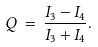<formula> <loc_0><loc_0><loc_500><loc_500>Q \, = \, \frac { I _ { 3 } - I _ { 4 } } { I _ { 3 } + I _ { 4 } } .</formula> 